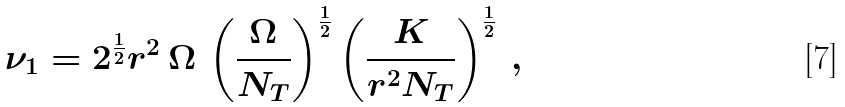Convert formula to latex. <formula><loc_0><loc_0><loc_500><loc_500>\nu _ { 1 } = 2 ^ { \frac { 1 } { 2 } } r ^ { 2 } \, \Omega \, \left ( \frac { \Omega } { N _ { T } } \right ) ^ { \frac { 1 } { 2 } } \left ( \frac { K } { r ^ { 2 } N _ { T } } \right ) ^ { \frac { 1 } { 2 } } \, ,</formula> 